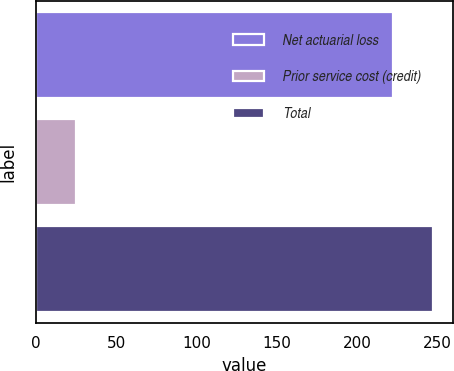<chart> <loc_0><loc_0><loc_500><loc_500><bar_chart><fcel>Net actuarial loss<fcel>Prior service cost (credit)<fcel>Total<nl><fcel>222<fcel>25<fcel>247<nl></chart> 